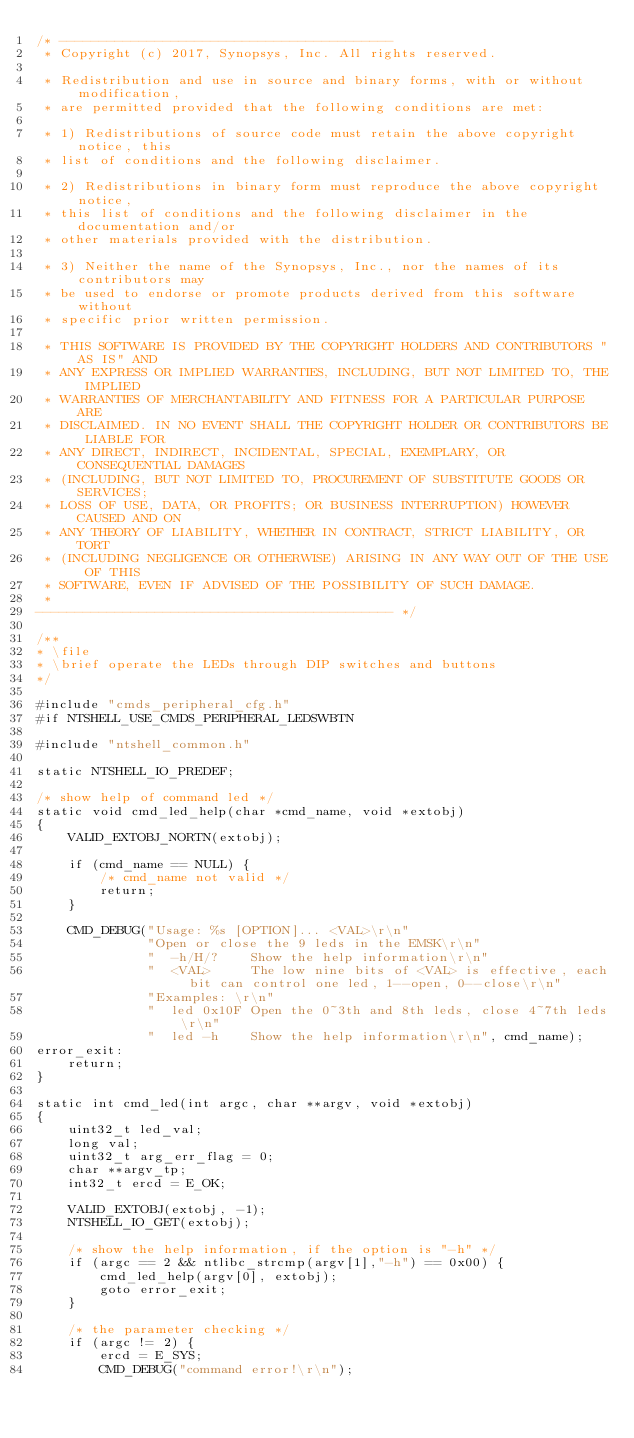<code> <loc_0><loc_0><loc_500><loc_500><_C_>/* ------------------------------------------
 * Copyright (c) 2017, Synopsys, Inc. All rights reserved.

 * Redistribution and use in source and binary forms, with or without modification,
 * are permitted provided that the following conditions are met:

 * 1) Redistributions of source code must retain the above copyright notice, this
 * list of conditions and the following disclaimer.

 * 2) Redistributions in binary form must reproduce the above copyright notice,
 * this list of conditions and the following disclaimer in the documentation and/or
 * other materials provided with the distribution.

 * 3) Neither the name of the Synopsys, Inc., nor the names of its contributors may
 * be used to endorse or promote products derived from this software without
 * specific prior written permission.

 * THIS SOFTWARE IS PROVIDED BY THE COPYRIGHT HOLDERS AND CONTRIBUTORS "AS IS" AND
 * ANY EXPRESS OR IMPLIED WARRANTIES, INCLUDING, BUT NOT LIMITED TO, THE IMPLIED
 * WARRANTIES OF MERCHANTABILITY AND FITNESS FOR A PARTICULAR PURPOSE ARE
 * DISCLAIMED. IN NO EVENT SHALL THE COPYRIGHT HOLDER OR CONTRIBUTORS BE LIABLE FOR
 * ANY DIRECT, INDIRECT, INCIDENTAL, SPECIAL, EXEMPLARY, OR CONSEQUENTIAL DAMAGES
 * (INCLUDING, BUT NOT LIMITED TO, PROCUREMENT OF SUBSTITUTE GOODS OR SERVICES;
 * LOSS OF USE, DATA, OR PROFITS; OR BUSINESS INTERRUPTION) HOWEVER CAUSED AND ON
 * ANY THEORY OF LIABILITY, WHETHER IN CONTRACT, STRICT LIABILITY, OR TORT
 * (INCLUDING NEGLIGENCE OR OTHERWISE) ARISING IN ANY WAY OUT OF THE USE OF THIS
 * SOFTWARE, EVEN IF ADVISED OF THE POSSIBILITY OF SUCH DAMAGE.
 *
--------------------------------------------- */

/**
* \file
* \brief operate the LEDs through DIP switches and buttons
*/

#include "cmds_peripheral_cfg.h"
#if NTSHELL_USE_CMDS_PERIPHERAL_LEDSWBTN

#include "ntshell_common.h"

static NTSHELL_IO_PREDEF;

/* show help of command led */
static void cmd_led_help(char *cmd_name, void *extobj)
{
	VALID_EXTOBJ_NORTN(extobj);

	if (cmd_name == NULL) {
		/* cmd_name not valid */
		return;
	}

	CMD_DEBUG("Usage: %s [OPTION]... <VAL>\r\n"
	          "Open or close the 9 leds in the EMSK\r\n"
	          "  -h/H/?    Show the help information\r\n"
	          "  <VAL>     The low nine bits of <VAL> is effective, each bit can control one led, 1--open, 0--close\r\n"
	          "Examples: \r\n"
	          "  led 0x10F Open the 0~3th and 8th leds, close 4~7th leds\r\n"
	          "  led -h    Show the help information\r\n", cmd_name);
error_exit:
	return;
}

static int cmd_led(int argc, char **argv, void *extobj)
{
	uint32_t led_val;
	long val;
	uint32_t arg_err_flag = 0;
	char **argv_tp;
	int32_t ercd = E_OK;

	VALID_EXTOBJ(extobj, -1);
	NTSHELL_IO_GET(extobj);

	/* show the help information, if the option is "-h" */
	if (argc == 2 && ntlibc_strcmp(argv[1],"-h") == 0x00) {
		cmd_led_help(argv[0], extobj);
		goto error_exit;
	}

	/* the parameter checking */
	if (argc != 2) {
		ercd = E_SYS;
		CMD_DEBUG("command error!\r\n");</code> 